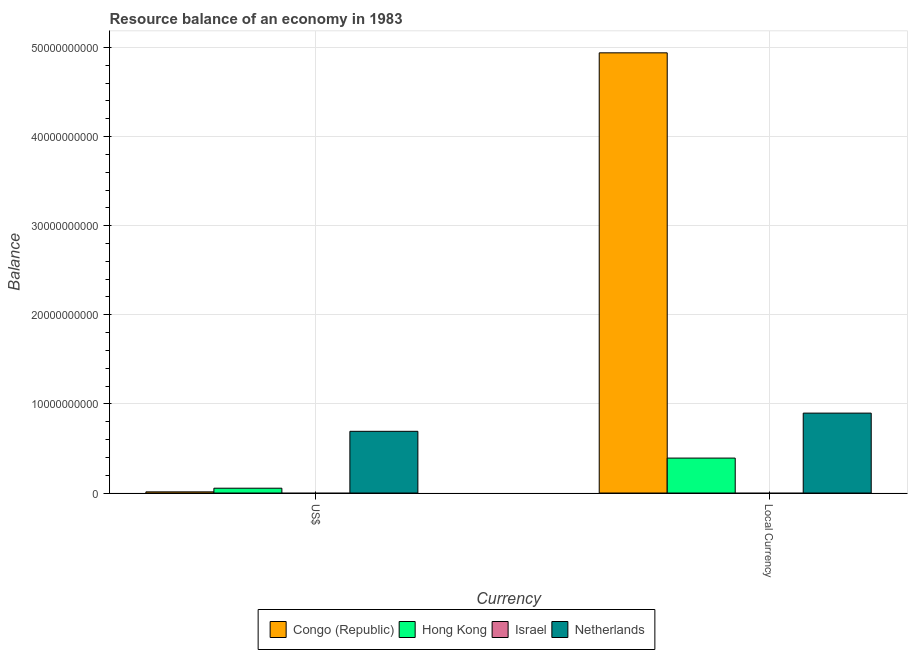How many groups of bars are there?
Provide a succinct answer. 2. Are the number of bars per tick equal to the number of legend labels?
Provide a short and direct response. No. How many bars are there on the 1st tick from the left?
Provide a short and direct response. 3. What is the label of the 1st group of bars from the left?
Your answer should be very brief. US$. What is the resource balance in us$ in Hong Kong?
Give a very brief answer. 5.40e+08. Across all countries, what is the maximum resource balance in us$?
Provide a short and direct response. 6.92e+09. Across all countries, what is the minimum resource balance in constant us$?
Provide a short and direct response. 0. What is the total resource balance in us$ in the graph?
Give a very brief answer. 7.59e+09. What is the difference between the resource balance in us$ in Hong Kong and that in Netherlands?
Offer a very short reply. -6.38e+09. What is the difference between the resource balance in constant us$ in Congo (Republic) and the resource balance in us$ in Hong Kong?
Keep it short and to the point. 4.89e+1. What is the average resource balance in us$ per country?
Keep it short and to the point. 1.90e+09. What is the difference between the resource balance in us$ and resource balance in constant us$ in Netherlands?
Your response must be concise. -2.04e+09. What is the ratio of the resource balance in us$ in Hong Kong to that in Congo (Republic)?
Provide a succinct answer. 4.16. In how many countries, is the resource balance in constant us$ greater than the average resource balance in constant us$ taken over all countries?
Provide a short and direct response. 1. How many bars are there?
Make the answer very short. 6. Are all the bars in the graph horizontal?
Provide a succinct answer. No. How many countries are there in the graph?
Your answer should be compact. 4. What is the difference between two consecutive major ticks on the Y-axis?
Provide a short and direct response. 1.00e+1. Does the graph contain any zero values?
Keep it short and to the point. Yes. Where does the legend appear in the graph?
Provide a succinct answer. Bottom center. How are the legend labels stacked?
Ensure brevity in your answer.  Horizontal. What is the title of the graph?
Offer a terse response. Resource balance of an economy in 1983. What is the label or title of the X-axis?
Provide a succinct answer. Currency. What is the label or title of the Y-axis?
Provide a succinct answer. Balance. What is the Balance of Congo (Republic) in US$?
Your response must be concise. 1.30e+08. What is the Balance in Hong Kong in US$?
Provide a succinct answer. 5.40e+08. What is the Balance in Netherlands in US$?
Offer a very short reply. 6.92e+09. What is the Balance of Congo (Republic) in Local Currency?
Ensure brevity in your answer.  4.94e+1. What is the Balance in Hong Kong in Local Currency?
Make the answer very short. 3.92e+09. What is the Balance of Netherlands in Local Currency?
Your response must be concise. 8.97e+09. Across all Currency, what is the maximum Balance in Congo (Republic)?
Provide a short and direct response. 4.94e+1. Across all Currency, what is the maximum Balance in Hong Kong?
Provide a short and direct response. 3.92e+09. Across all Currency, what is the maximum Balance of Netherlands?
Your answer should be very brief. 8.97e+09. Across all Currency, what is the minimum Balance of Congo (Republic)?
Provide a succinct answer. 1.30e+08. Across all Currency, what is the minimum Balance in Hong Kong?
Offer a very short reply. 5.40e+08. Across all Currency, what is the minimum Balance of Netherlands?
Ensure brevity in your answer.  6.92e+09. What is the total Balance in Congo (Republic) in the graph?
Keep it short and to the point. 4.95e+1. What is the total Balance of Hong Kong in the graph?
Your answer should be compact. 4.46e+09. What is the total Balance in Israel in the graph?
Ensure brevity in your answer.  0. What is the total Balance of Netherlands in the graph?
Offer a terse response. 1.59e+1. What is the difference between the Balance in Congo (Republic) in US$ and that in Local Currency?
Ensure brevity in your answer.  -4.93e+1. What is the difference between the Balance of Hong Kong in US$ and that in Local Currency?
Keep it short and to the point. -3.38e+09. What is the difference between the Balance in Netherlands in US$ and that in Local Currency?
Offer a very short reply. -2.04e+09. What is the difference between the Balance of Congo (Republic) in US$ and the Balance of Hong Kong in Local Currency?
Offer a terse response. -3.79e+09. What is the difference between the Balance of Congo (Republic) in US$ and the Balance of Netherlands in Local Currency?
Offer a terse response. -8.84e+09. What is the difference between the Balance in Hong Kong in US$ and the Balance in Netherlands in Local Currency?
Your response must be concise. -8.43e+09. What is the average Balance of Congo (Republic) per Currency?
Keep it short and to the point. 2.48e+1. What is the average Balance of Hong Kong per Currency?
Make the answer very short. 2.23e+09. What is the average Balance of Israel per Currency?
Your answer should be compact. 0. What is the average Balance of Netherlands per Currency?
Provide a succinct answer. 7.95e+09. What is the difference between the Balance of Congo (Republic) and Balance of Hong Kong in US$?
Ensure brevity in your answer.  -4.10e+08. What is the difference between the Balance of Congo (Republic) and Balance of Netherlands in US$?
Provide a succinct answer. -6.79e+09. What is the difference between the Balance in Hong Kong and Balance in Netherlands in US$?
Your response must be concise. -6.38e+09. What is the difference between the Balance of Congo (Republic) and Balance of Hong Kong in Local Currency?
Provide a short and direct response. 4.55e+1. What is the difference between the Balance of Congo (Republic) and Balance of Netherlands in Local Currency?
Ensure brevity in your answer.  4.04e+1. What is the difference between the Balance of Hong Kong and Balance of Netherlands in Local Currency?
Keep it short and to the point. -5.05e+09. What is the ratio of the Balance in Congo (Republic) in US$ to that in Local Currency?
Offer a terse response. 0. What is the ratio of the Balance of Hong Kong in US$ to that in Local Currency?
Your answer should be very brief. 0.14. What is the ratio of the Balance of Netherlands in US$ to that in Local Currency?
Offer a terse response. 0.77. What is the difference between the highest and the second highest Balance of Congo (Republic)?
Keep it short and to the point. 4.93e+1. What is the difference between the highest and the second highest Balance of Hong Kong?
Offer a terse response. 3.38e+09. What is the difference between the highest and the second highest Balance in Netherlands?
Your answer should be very brief. 2.04e+09. What is the difference between the highest and the lowest Balance in Congo (Republic)?
Give a very brief answer. 4.93e+1. What is the difference between the highest and the lowest Balance of Hong Kong?
Your answer should be very brief. 3.38e+09. What is the difference between the highest and the lowest Balance of Netherlands?
Provide a succinct answer. 2.04e+09. 